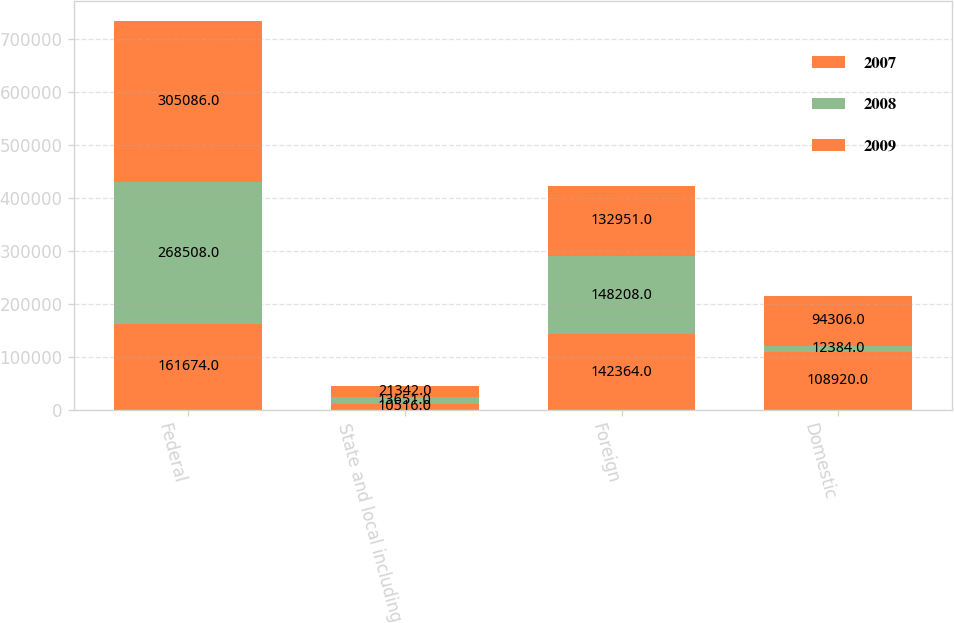Convert chart to OTSL. <chart><loc_0><loc_0><loc_500><loc_500><stacked_bar_chart><ecel><fcel>Federal<fcel>State and local including<fcel>Foreign<fcel>Domestic<nl><fcel>2007<fcel>161674<fcel>10516<fcel>142364<fcel>108920<nl><fcel>2008<fcel>268508<fcel>13651<fcel>148208<fcel>12384<nl><fcel>2009<fcel>305086<fcel>21342<fcel>132951<fcel>94306<nl></chart> 